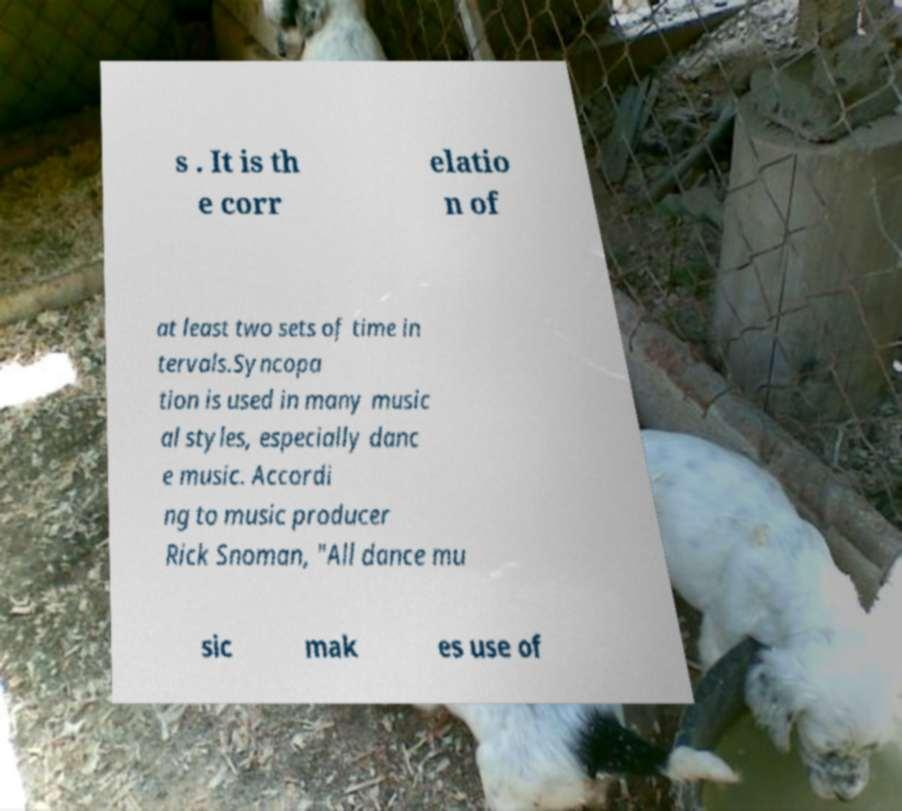Can you accurately transcribe the text from the provided image for me? s . It is th e corr elatio n of at least two sets of time in tervals.Syncopa tion is used in many music al styles, especially danc e music. Accordi ng to music producer Rick Snoman, "All dance mu sic mak es use of 